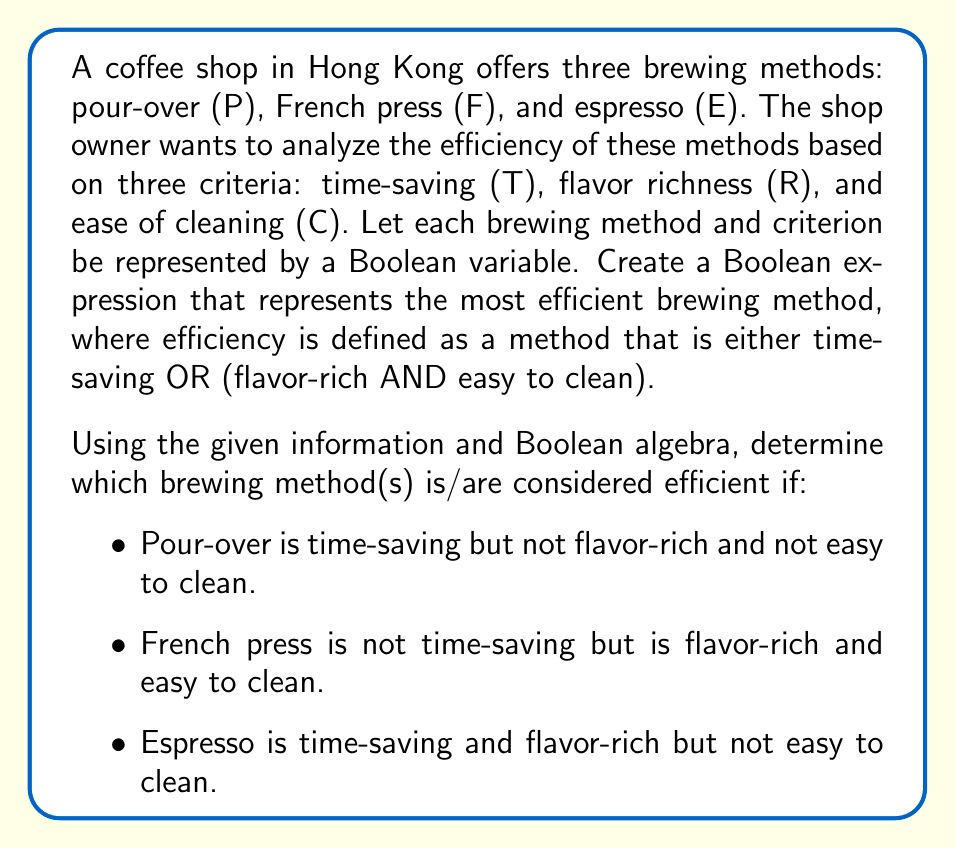Teach me how to tackle this problem. Let's approach this step-by-step:

1) First, let's define our Boolean variables:
   P: Pour-over
   F: French press
   E: Espresso
   T: Time-saving
   R: Flavor-rich
   C: Easy to clean

2) The efficiency condition can be expressed as: $E = T + (R \cdot C)$

3) Now, let's create truth tables for each brewing method based on the given information:

   Pour-over (P):
   T = 1, R = 0, C = 0
   $E_P = 1 + (0 \cdot 0) = 1$

   French press (F):
   T = 0, R = 1, C = 1
   $E_F = 0 + (1 \cdot 1) = 1$

   Espresso (E):
   T = 1, R = 1, C = 0
   $E_E = 1 + (1 \cdot 0) = 1$

4) We can represent the overall efficiency of the brewing methods using the following Boolean expression:

   $E_{total} = P \cdot E_P + F \cdot E_F + E \cdot E_E$

5) Substituting the values we calculated:

   $E_{total} = P \cdot 1 + F \cdot 1 + E \cdot 1 = P + F + E$

This means that all three brewing methods are considered efficient according to our criteria.
Answer: All three brewing methods (pour-over, French press, and espresso) are efficient according to the given criteria. The Boolean expression representing the efficient brewing methods is $E_{total} = P + F + E$. 